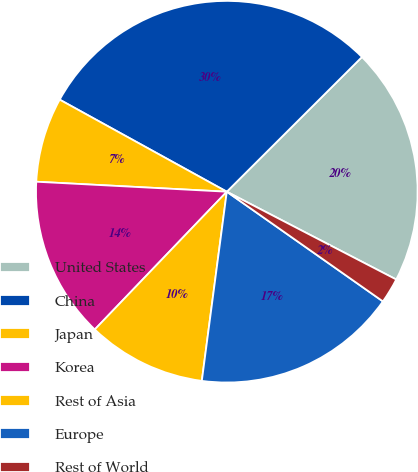Convert chart to OTSL. <chart><loc_0><loc_0><loc_500><loc_500><pie_chart><fcel>United States<fcel>China<fcel>Japan<fcel>Korea<fcel>Rest of Asia<fcel>Europe<fcel>Rest of World<nl><fcel>20.08%<fcel>29.51%<fcel>7.18%<fcel>13.67%<fcel>10.07%<fcel>17.34%<fcel>2.14%<nl></chart> 